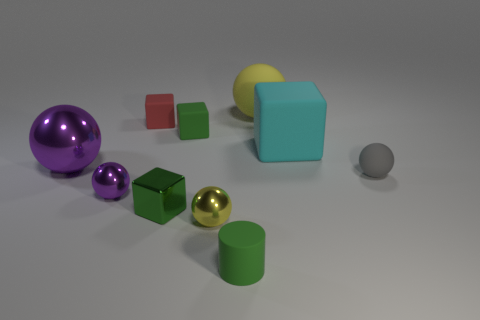Can you describe the positioning of the spheres in relation to each other? Certainly! There are three spheres in the image, each a different size and color. The largest sphere is purple, located to the left side of the frame. To its right is the medium-sized yellow sphere, and finally, the smallest sphere, which is gray, is also to the right but closer to the front of the image. 